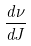Convert formula to latex. <formula><loc_0><loc_0><loc_500><loc_500>\frac { d \nu } { d J }</formula> 